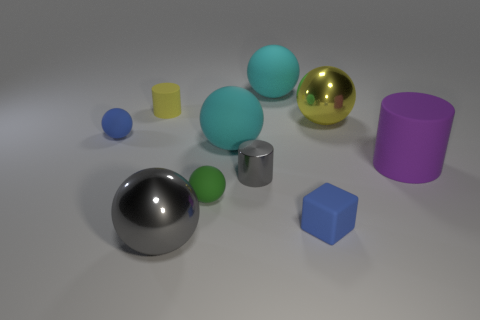There is a tiny sphere that is in front of the tiny blue ball; what is it made of?
Your answer should be compact. Rubber. What material is the gray cylinder?
Offer a terse response. Metal. There is a large matte object behind the large metal thing right of the metallic ball that is in front of the tiny green rubber thing; what is its shape?
Provide a succinct answer. Sphere. Are there more small blue matte things on the right side of the gray metallic cylinder than tiny green rubber cubes?
Your answer should be very brief. Yes. Do the large purple object and the tiny gray object on the right side of the yellow cylinder have the same shape?
Make the answer very short. Yes. What shape is the big object that is the same color as the small metallic cylinder?
Make the answer very short. Sphere. What number of metallic spheres are in front of the small ball that is right of the blue matte thing to the left of the gray metallic ball?
Your answer should be very brief. 1. The metal cylinder that is the same size as the blue rubber cube is what color?
Your response must be concise. Gray. There is a blue thing that is in front of the blue rubber object behind the green matte sphere; how big is it?
Ensure brevity in your answer.  Small. There is a object that is the same color as the rubber cube; what is its size?
Offer a very short reply. Small. 